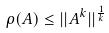Convert formula to latex. <formula><loc_0><loc_0><loc_500><loc_500>\rho ( A ) \leq | | A ^ { k } | | ^ { \frac { 1 } { k } }</formula> 